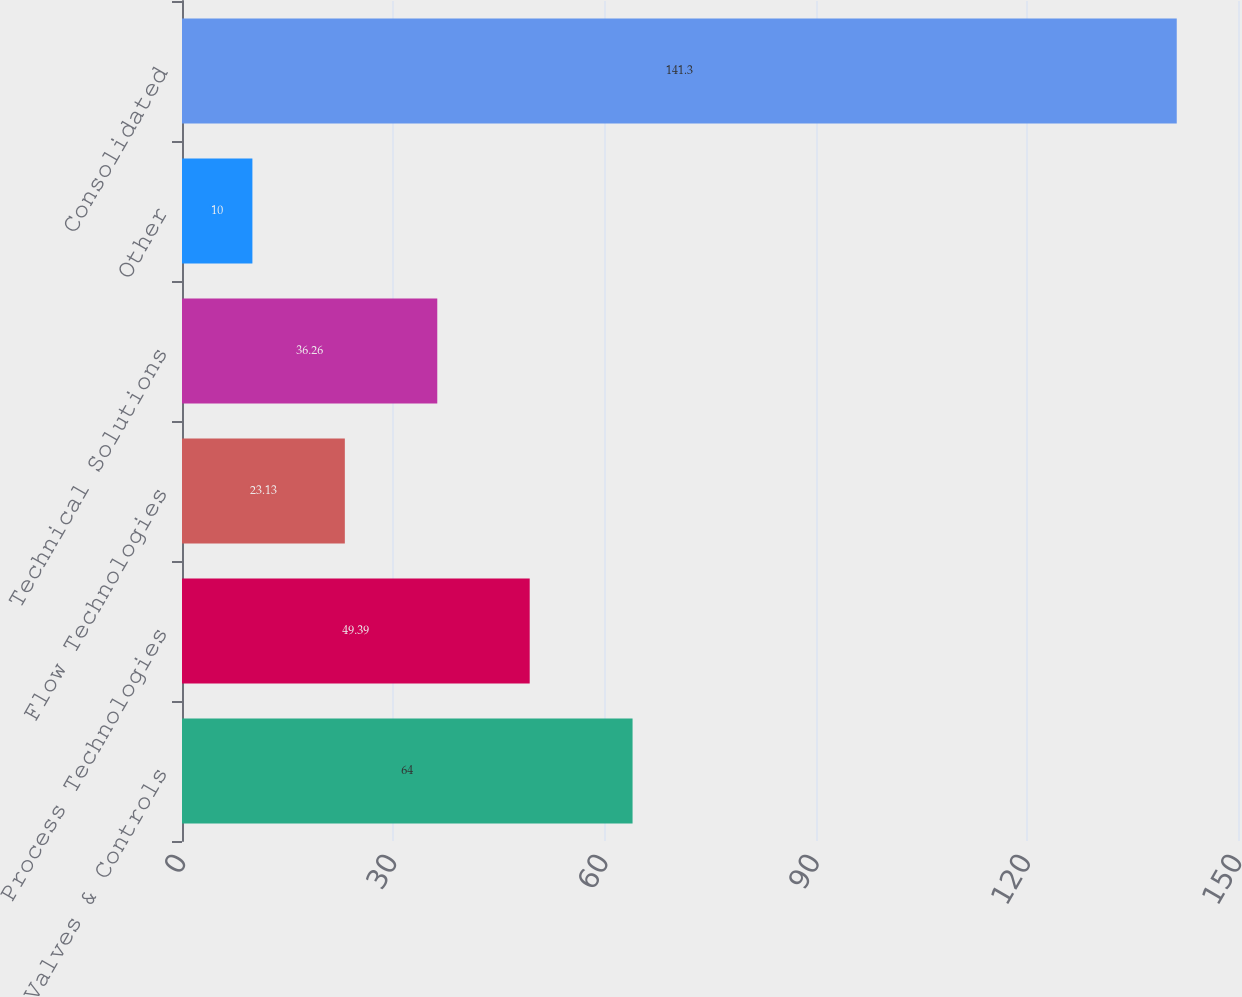Convert chart. <chart><loc_0><loc_0><loc_500><loc_500><bar_chart><fcel>Valves & Controls<fcel>Process Technologies<fcel>Flow Technologies<fcel>Technical Solutions<fcel>Other<fcel>Consolidated<nl><fcel>64<fcel>49.39<fcel>23.13<fcel>36.26<fcel>10<fcel>141.3<nl></chart> 